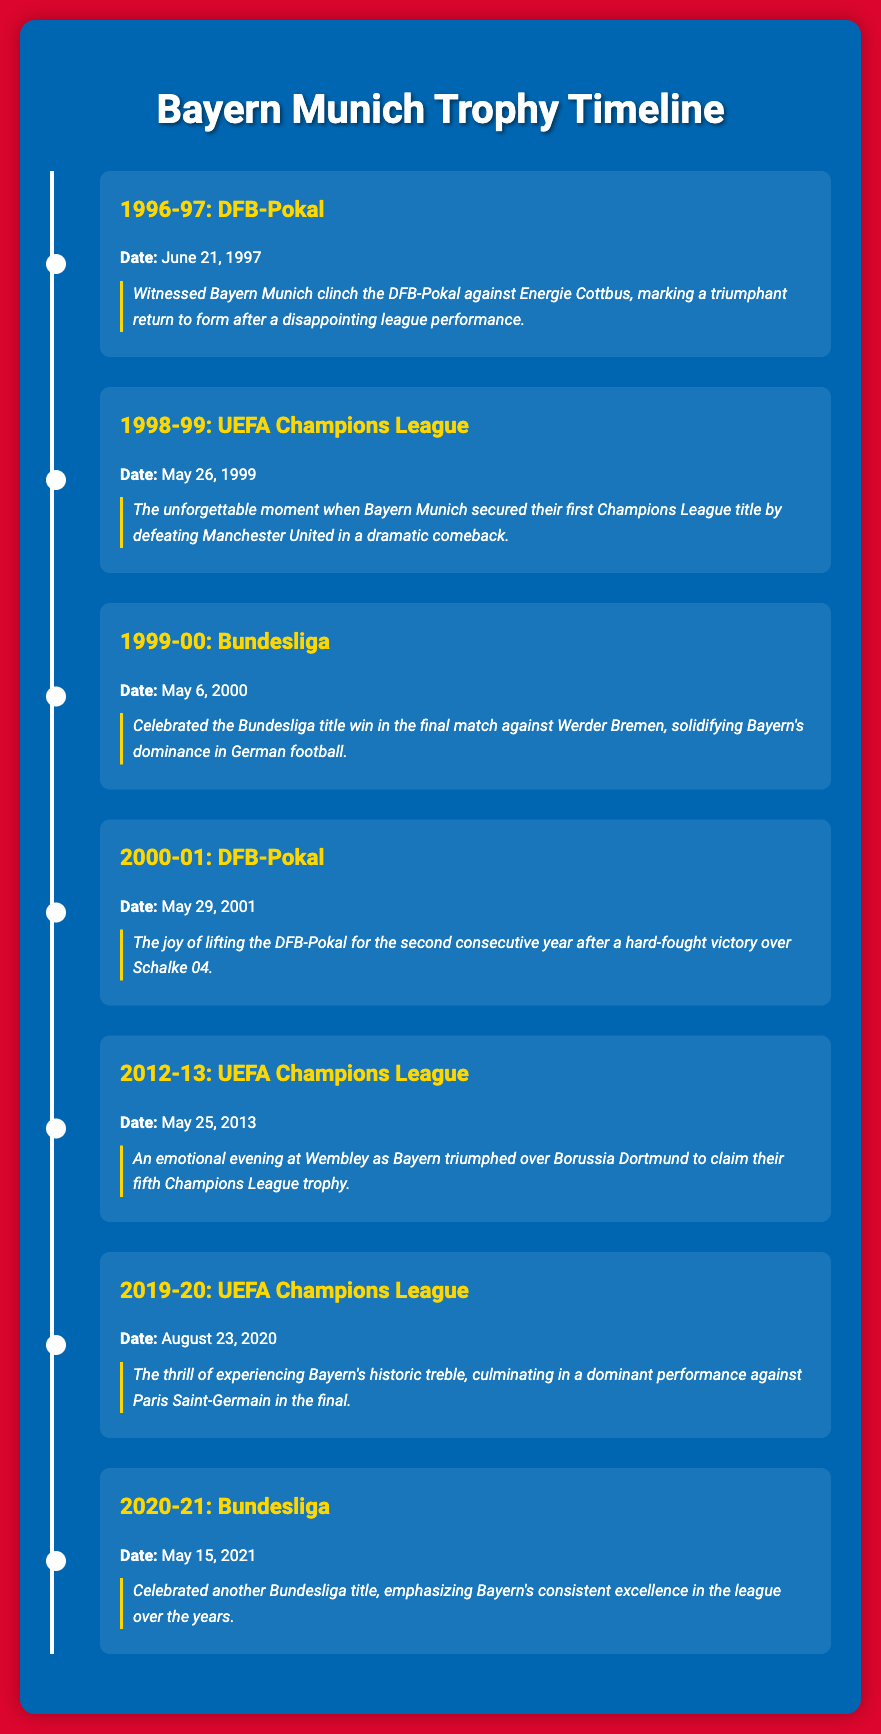What trophy did Bayern Munich win in 1996-97? This refers to the specific event listed for that year, which is the DFB-Pokal.
Answer: DFB-Pokal What was the date of Bayern Munich's 1998-99 Champions League victory? The date is explicitly mentioned in the document for the UEFA Champions League win in that year.
Answer: May 26, 1999 How many Bundesliga titles did Bayern Munich win as listed in the document? The document highlights a total of two Bundesliga wins: one in 1999-00 and another in 2020-21.
Answer: 2 Which team did Bayern Munich defeat to win the 2012-13 UEFA Champions League? This refers to the opponent mentioned in the event description for that match.
Answer: Borussia Dortmund What highlight is associated with the 2019-20 UEFA Champions League victory? The specific highlight discusses the thrill of experiencing Bayern's historic treble and the opponent in the final.
Answer: Dominant performance against Paris Saint-Germain In which season did Bayern Munich win their first UEFA Champions League title? This is derived from the specific season mentioned in the document that pertains to the first Champions League win.
Answer: 1998-99 What year did Bayern Munich win the DFB-Pokal for the second consecutive time? This refers to the event listed under the 2000-01 season, where they lifted the DFB-Pokal again.
Answer: 2001 How many trophy wins are detailed in the timeline? The document presents a total of seven distinct events showcasing Bayern Munich’s trophy wins.
Answer: 7 